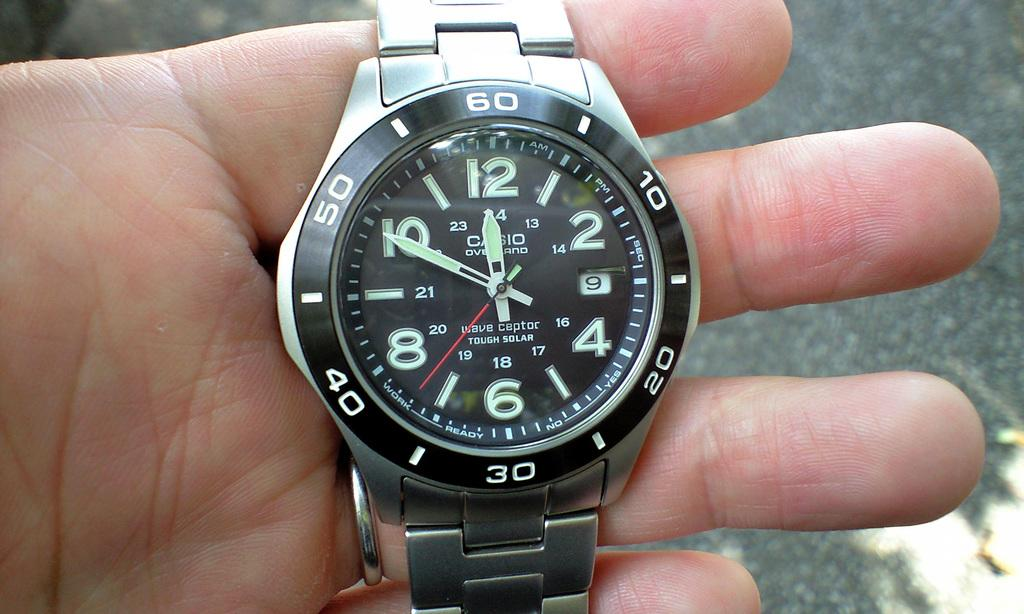<image>
Write a terse but informative summary of the picture. A silver Casio watch is being held in the hand of a person. 